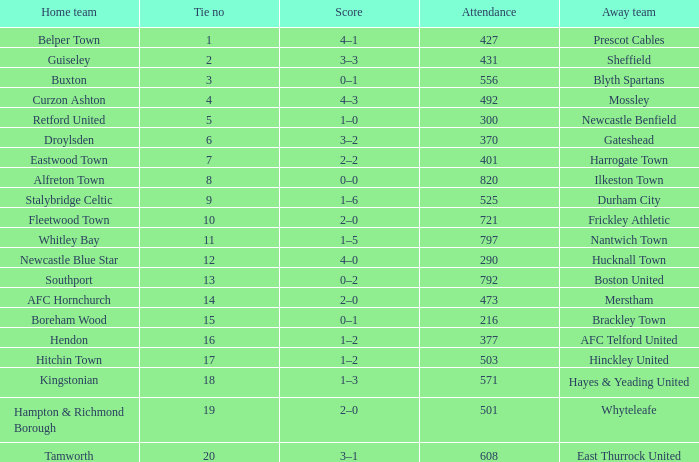What was the score for home team AFC Hornchurch? 2–0. 